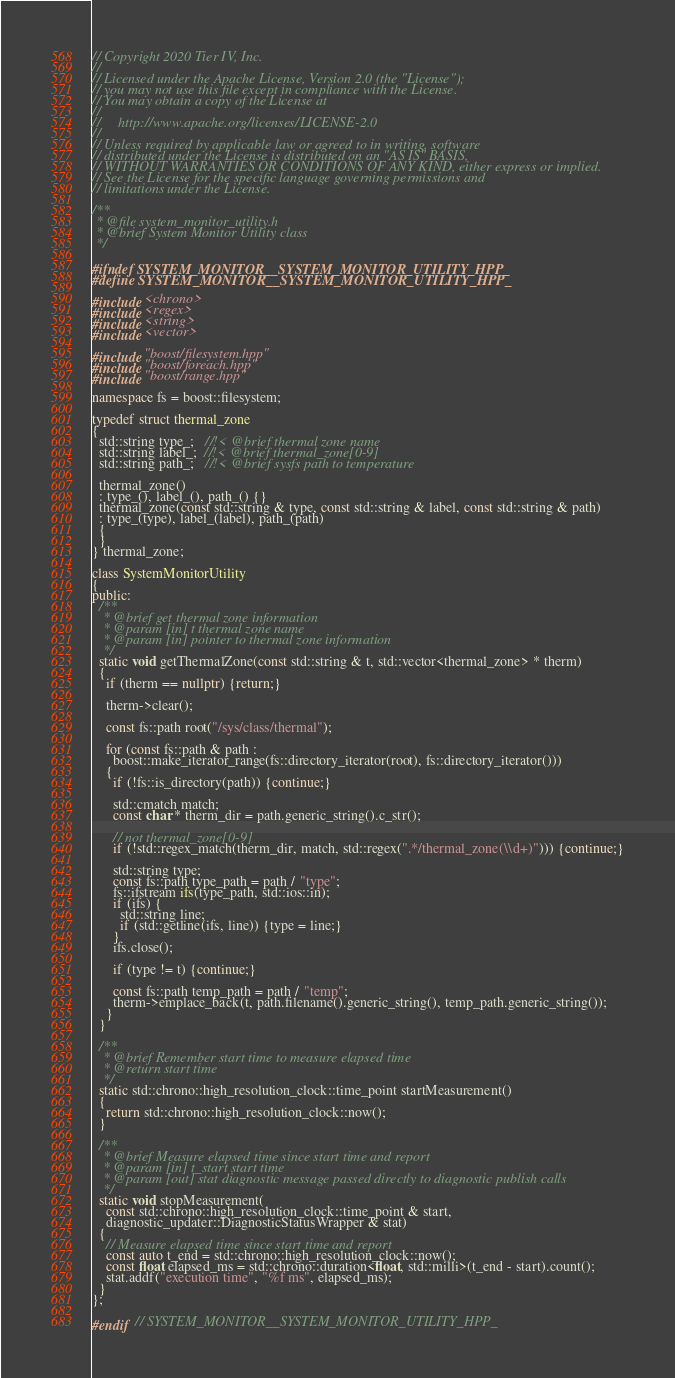<code> <loc_0><loc_0><loc_500><loc_500><_C++_>// Copyright 2020 Tier IV, Inc.
//
// Licensed under the Apache License, Version 2.0 (the "License");
// you may not use this file except in compliance with the License.
// You may obtain a copy of the License at
//
//     http://www.apache.org/licenses/LICENSE-2.0
//
// Unless required by applicable law or agreed to in writing, software
// distributed under the License is distributed on an "AS IS" BASIS,
// WITHOUT WARRANTIES OR CONDITIONS OF ANY KIND, either express or implied.
// See the License for the specific language governing permissions and
// limitations under the License.

/**
 * @file system_monitor_utility.h
 * @brief System Monitor Utility class
 */

#ifndef SYSTEM_MONITOR__SYSTEM_MONITOR_UTILITY_HPP_
#define SYSTEM_MONITOR__SYSTEM_MONITOR_UTILITY_HPP_

#include <chrono>
#include <regex>
#include <string>
#include <vector>

#include "boost/filesystem.hpp"
#include "boost/foreach.hpp"
#include "boost/range.hpp"

namespace fs = boost::filesystem;

typedef struct thermal_zone
{
  std::string type_;   //!< @brief thermal zone name
  std::string label_;  //!< @brief thermal_zone[0-9]
  std::string path_;   //!< @brief sysfs path to temperature

  thermal_zone()
  : type_(), label_(), path_() {}
  thermal_zone(const std::string & type, const std::string & label, const std::string & path)
  : type_(type), label_(label), path_(path)
  {
  }
} thermal_zone;

class SystemMonitorUtility
{
public:
  /**
   * @brief get thermal zone information
   * @param [in] t thermal zone name
   * @param [in] pointer to thermal zone information
   */
  static void getThermalZone(const std::string & t, std::vector<thermal_zone> * therm)
  {
    if (therm == nullptr) {return;}

    therm->clear();

    const fs::path root("/sys/class/thermal");

    for (const fs::path & path :
      boost::make_iterator_range(fs::directory_iterator(root), fs::directory_iterator()))
    {
      if (!fs::is_directory(path)) {continue;}

      std::cmatch match;
      const char * therm_dir = path.generic_string().c_str();

      // not thermal_zone[0-9]
      if (!std::regex_match(therm_dir, match, std::regex(".*/thermal_zone(\\d+)"))) {continue;}

      std::string type;
      const fs::path type_path = path / "type";
      fs::ifstream ifs(type_path, std::ios::in);
      if (ifs) {
        std::string line;
        if (std::getline(ifs, line)) {type = line;}
      }
      ifs.close();

      if (type != t) {continue;}

      const fs::path temp_path = path / "temp";
      therm->emplace_back(t, path.filename().generic_string(), temp_path.generic_string());
    }
  }

  /**
   * @brief Remember start time to measure elapsed time
   * @return start time
   */
  static std::chrono::high_resolution_clock::time_point startMeasurement()
  {
    return std::chrono::high_resolution_clock::now();
  }

  /**
   * @brief Measure elapsed time since start time and report
   * @param [in] t_start start time
   * @param [out] stat diagnostic message passed directly to diagnostic publish calls
   */
  static void stopMeasurement(
    const std::chrono::high_resolution_clock::time_point & start,
    diagnostic_updater::DiagnosticStatusWrapper & stat)
  {
    // Measure elapsed time since start time and report
    const auto t_end = std::chrono::high_resolution_clock::now();
    const float elapsed_ms = std::chrono::duration<float, std::milli>(t_end - start).count();
    stat.addf("execution time", "%f ms", elapsed_ms);
  }
};

#endif  // SYSTEM_MONITOR__SYSTEM_MONITOR_UTILITY_HPP_
</code> 